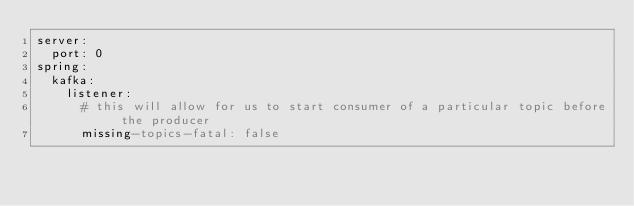Convert code to text. <code><loc_0><loc_0><loc_500><loc_500><_YAML_>server:
  port: 0
spring:
  kafka:
    listener:
      # this will allow for us to start consumer of a particular topic before the producer
      missing-topics-fatal: false
</code> 